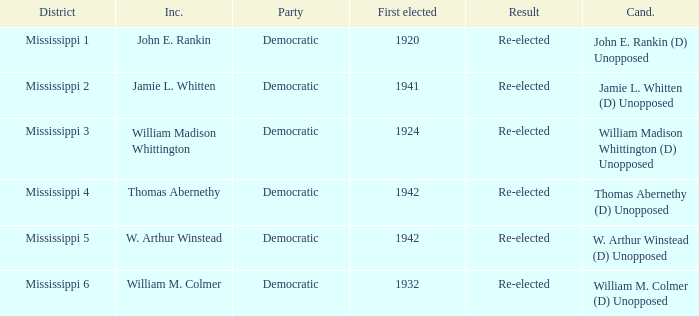Which district is jamie l. whitten from? Mississippi 2. 